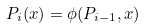Convert formula to latex. <formula><loc_0><loc_0><loc_500><loc_500>P _ { i } ( x ) = \phi ( P _ { i - 1 } , x )</formula> 